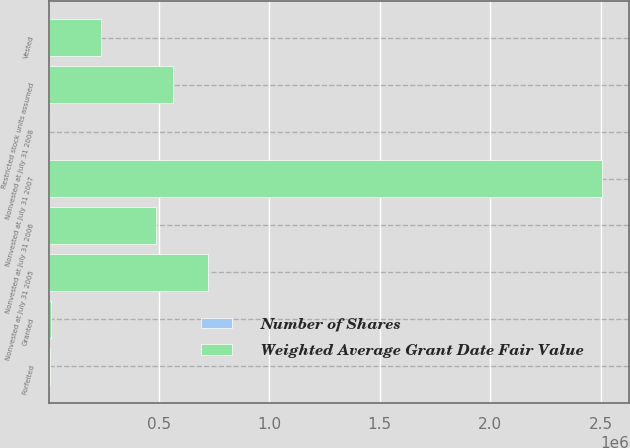<chart> <loc_0><loc_0><loc_500><loc_500><stacked_bar_chart><ecel><fcel>Nonvested at July 31 2005<fcel>Granted<fcel>Vested<fcel>Forfeited<fcel>Nonvested at July 31 2006<fcel>Nonvested at July 31 2007<fcel>Restricted stock units assumed<fcel>Nonvested at July 31 2008<nl><fcel>Weighted Average Grant Date Fair Value<fcel>719840<fcel>11916<fcel>239316<fcel>4204<fcel>488236<fcel>2.50469e+06<fcel>561887<fcel>29.88<nl><fcel>Number of Shares<fcel>22.6<fcel>24.58<fcel>22.18<fcel>23.99<fcel>23.03<fcel>29.88<fcel>29.78<fcel>29.29<nl></chart> 